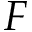<formula> <loc_0><loc_0><loc_500><loc_500>F</formula> 